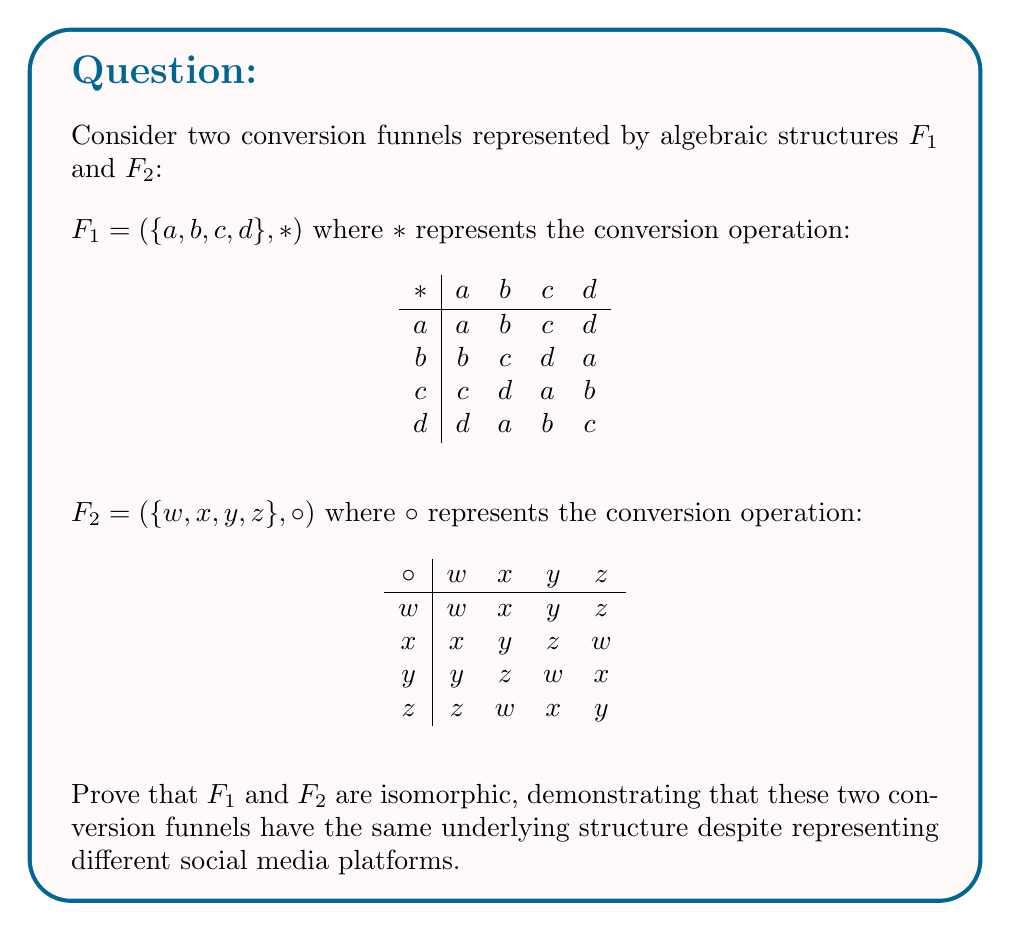Teach me how to tackle this problem. To prove that $F_1$ and $F_2$ are isomorphic, we need to find a bijective function $f: F_1 \to F_2$ that preserves the operation. Let's approach this step-by-step:

1) First, let's define a function $f: F_1 \to F_2$ as follows:
   $f(a) = w$, $f(b) = x$, $f(c) = y$, $f(d) = z$

2) We need to verify that this function is bijective:
   - It's injective (one-to-one) because each element in $F_1$ maps to a unique element in $F_2$.
   - It's surjective (onto) because every element in $F_2$ is mapped to by an element in $F_1$.
   Therefore, $f$ is bijective.

3) Now, we need to show that $f$ preserves the operation, i.e., for all $x, y \in F_1$:
   $f(x * y) = f(x) \circ f(y)$

4) Let's verify this for all possible combinations:
   - $f(a * a) = f(a) = w = w \circ w = f(a) \circ f(a)$
   - $f(a * b) = f(b) = x = w \circ x = f(a) \circ f(b)$
   - $f(a * c) = f(c) = y = w \circ y = f(a) \circ f(c)$
   - $f(a * d) = f(d) = z = w \circ z = f(a) \circ f(d)$
   - $f(b * a) = f(b) = x = x \circ w = f(b) \circ f(a)$
   - $f(b * b) = f(c) = y = x \circ x = f(b) \circ f(b)$
   - $f(b * c) = f(d) = z = x \circ y = f(b) \circ f(c)$
   - $f(b * d) = f(a) = w = x \circ z = f(b) \circ f(d)$

   (We can continue this verification for all 16 possible combinations)

5) Since the function $f$ is bijective and preserves the operation for all elements, we have proven that $F_1$ and $F_2$ are isomorphic.

This isomorphism demonstrates that despite representing different social media platforms, these two conversion funnels have the same underlying algebraic structure. This implies that strategies and insights from one platform can be potentially applied to the other, given the structural similarity in their conversion processes.
Answer: $F_1 \cong F_2$ via $f: F_1 \to F_2$ where $f(a) = w$, $f(b) = x$, $f(c) = y$, $f(d) = z$ 